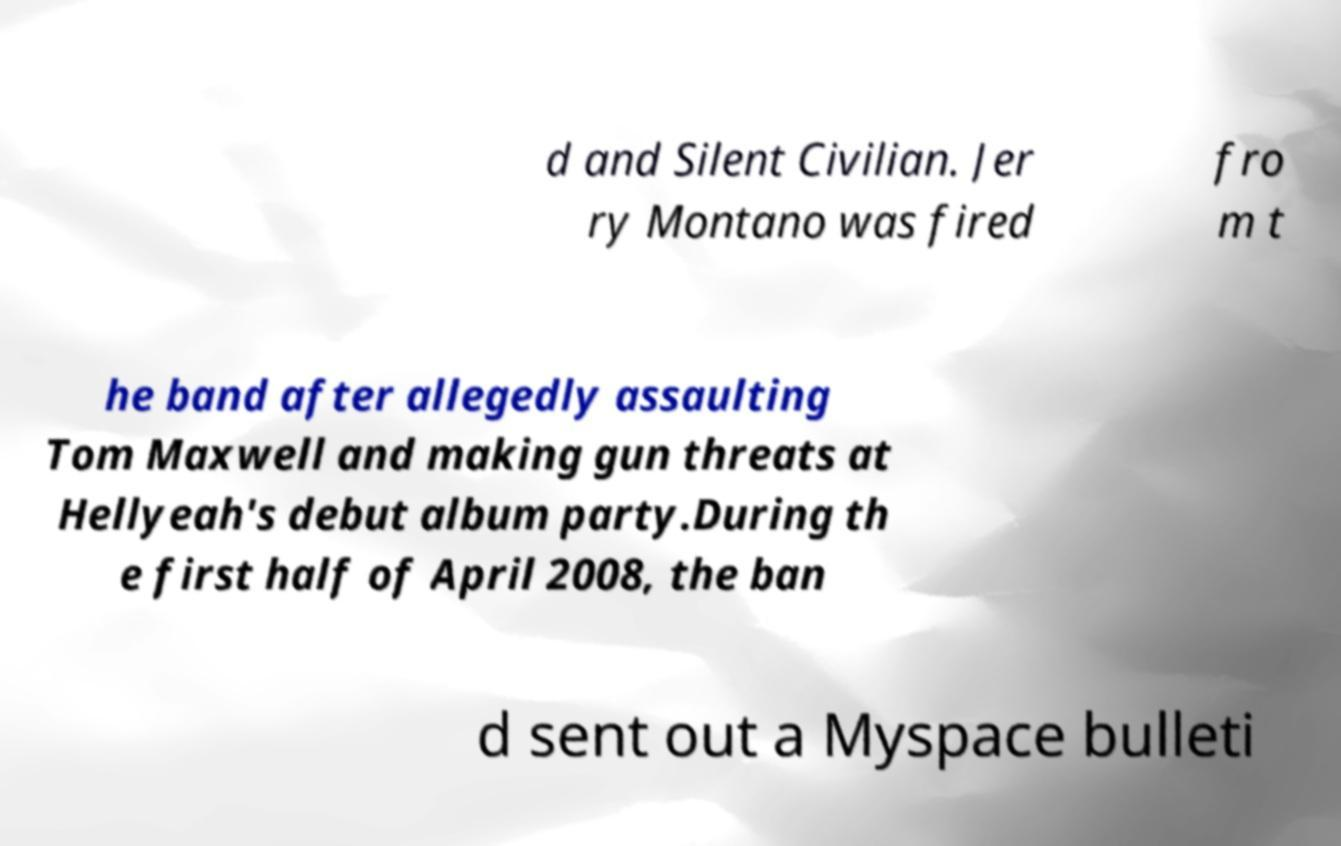There's text embedded in this image that I need extracted. Can you transcribe it verbatim? d and Silent Civilian. Jer ry Montano was fired fro m t he band after allegedly assaulting Tom Maxwell and making gun threats at Hellyeah's debut album party.During th e first half of April 2008, the ban d sent out a Myspace bulleti 